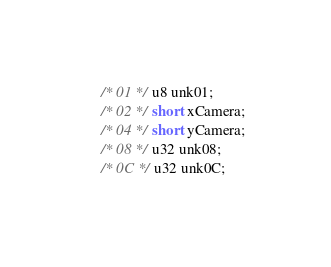<code> <loc_0><loc_0><loc_500><loc_500><_C_>	/* 01 */ u8 unk01;
	/* 02 */ short xCamera;
	/* 04 */ short yCamera;
	/* 08 */ u32 unk08;
	/* 0C */ u32 unk0C;</code> 